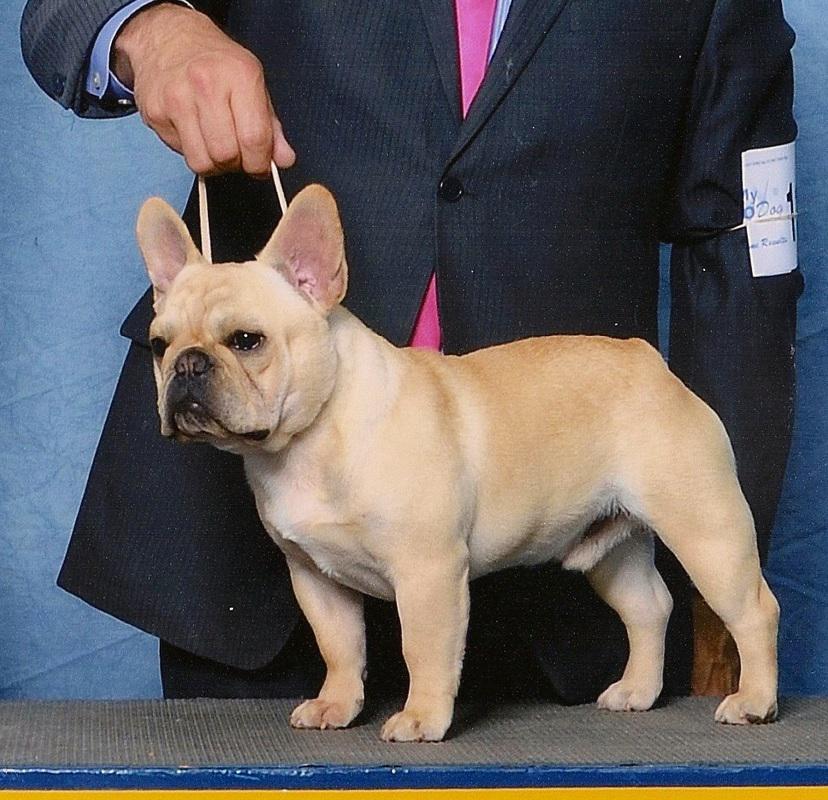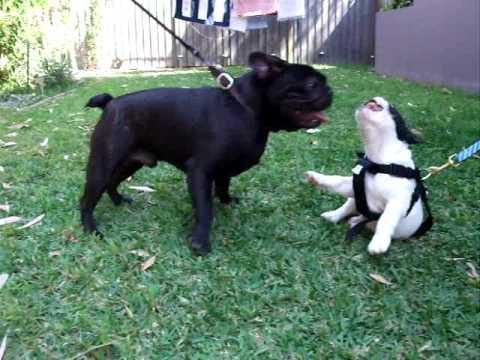The first image is the image on the left, the second image is the image on the right. Examine the images to the left and right. Is the description "One image contains a single light-colored dog, and the other includes a black dog standing on all fours." accurate? Answer yes or no. Yes. The first image is the image on the left, the second image is the image on the right. For the images displayed, is the sentence "There are at least three dogs." factually correct? Answer yes or no. Yes. 